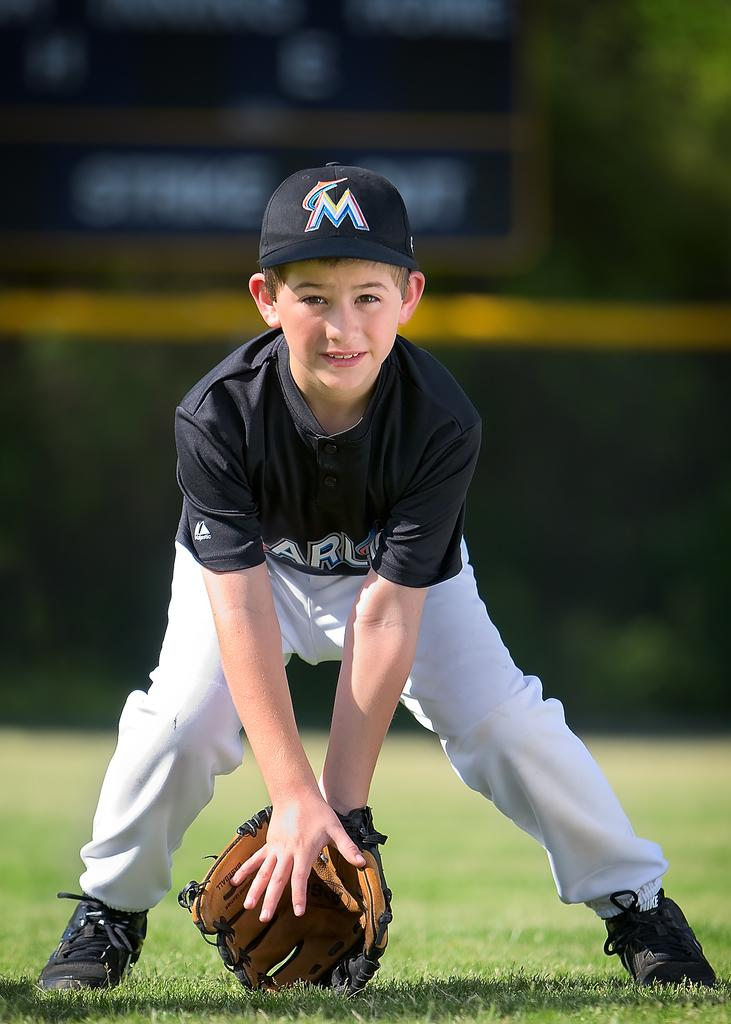What is the main subject of the image? There is a person in the image. What else can be seen in the image besides the person? There is an object in the image. Can you describe the background of the image? The background of the image is blurred. What type of natural environment is visible at the bottom of the image? There is grass at the bottom of the image. How many flowers can be seen growing in the grass in the image? There are no flowers visible in the image; only grass is present at the bottom of the image. What type of babies are being measured in the image? There are no babies present in the image, nor is there any indication of measuring anything. 